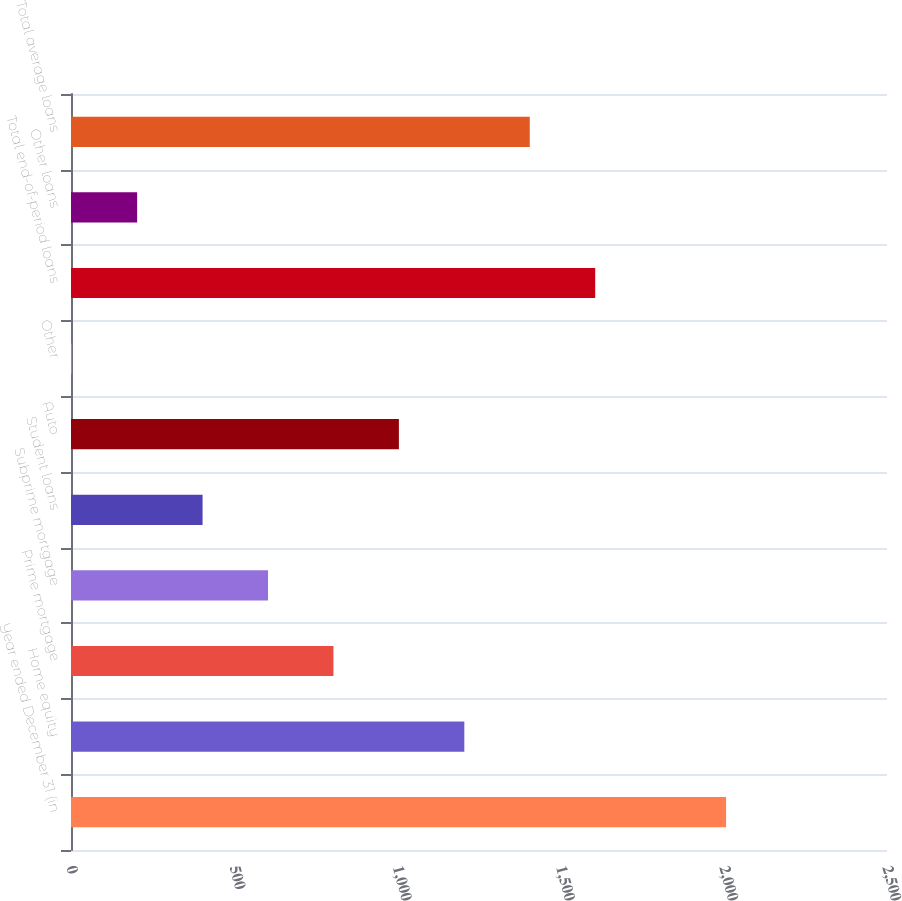<chart> <loc_0><loc_0><loc_500><loc_500><bar_chart><fcel>Year ended December 31 (in<fcel>Home equity<fcel>Prime mortgage<fcel>Subprime mortgage<fcel>Student loans<fcel>Auto<fcel>Other<fcel>Total end-of-period loans<fcel>Other loans<fcel>Total average loans<nl><fcel>2007<fcel>1205.04<fcel>804.06<fcel>603.57<fcel>403.08<fcel>1004.55<fcel>2.1<fcel>1606.02<fcel>202.59<fcel>1405.53<nl></chart> 